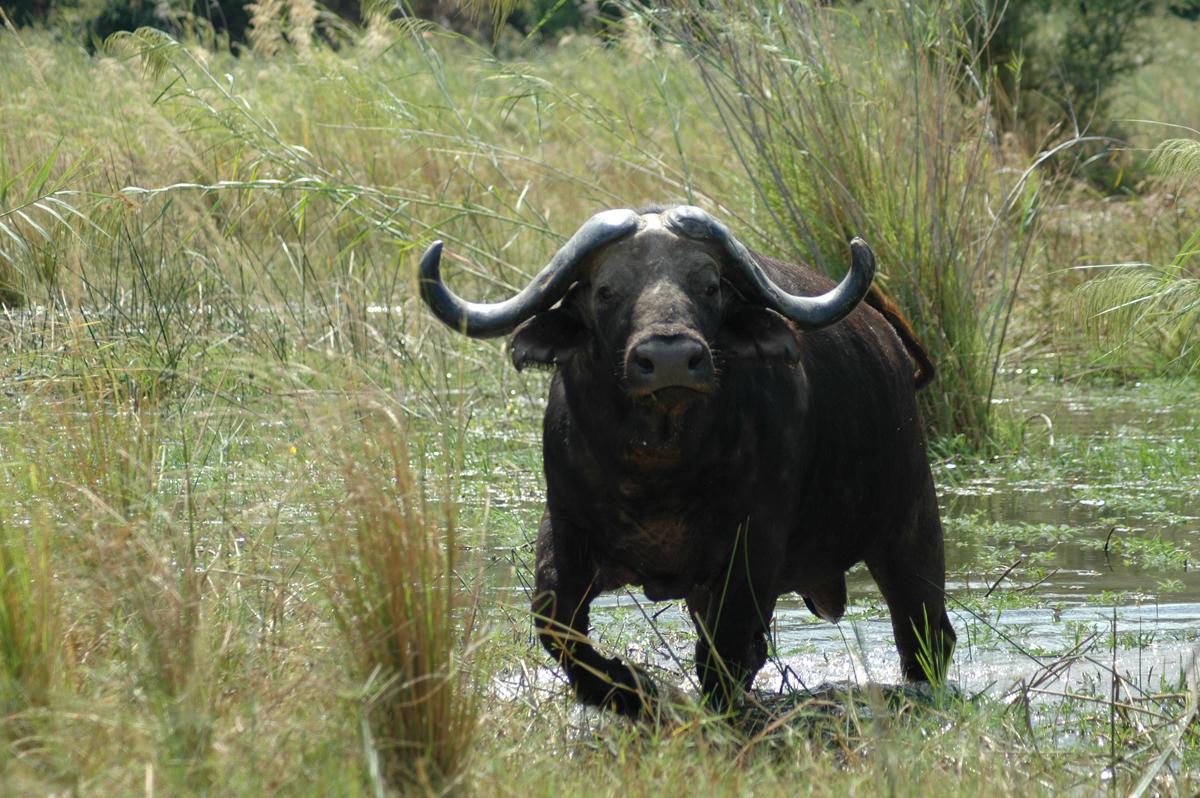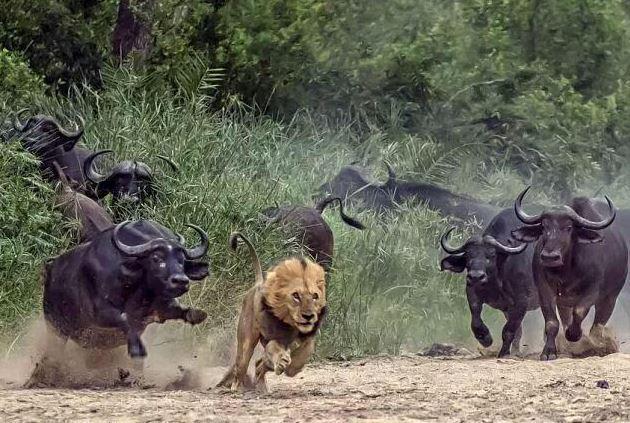The first image is the image on the left, the second image is the image on the right. Evaluate the accuracy of this statement regarding the images: "There are exactly two African buffalo.". Is it true? Answer yes or no. No. The first image is the image on the left, the second image is the image on the right. Considering the images on both sides, is "The left image features one camera-gazing water buffalo that is standing directly in front of a wet area." valid? Answer yes or no. Yes. 